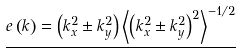Convert formula to latex. <formula><loc_0><loc_0><loc_500><loc_500>\underline { e \left ( { k } \right ) = \left ( k ^ { 2 } _ { x } \pm k ^ { 2 } _ { y } \right ) \left < \left ( k ^ { 2 } _ { x } \pm k ^ { 2 } _ { y } \right ) ^ { 2 } \right > ^ { - 1 / 2 } } \,</formula> 